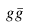<formula> <loc_0><loc_0><loc_500><loc_500>g { \bar { g } }</formula> 